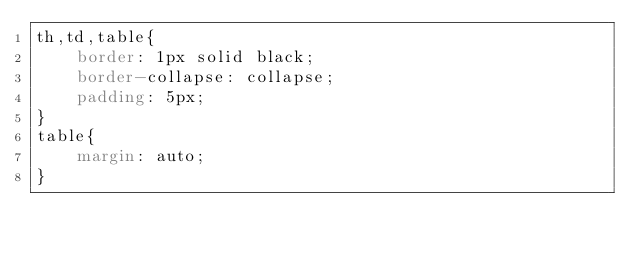Convert code to text. <code><loc_0><loc_0><loc_500><loc_500><_CSS_>th,td,table{
    border: 1px solid black;
    border-collapse: collapse;
    padding: 5px;
}
table{
    margin: auto;
}</code> 